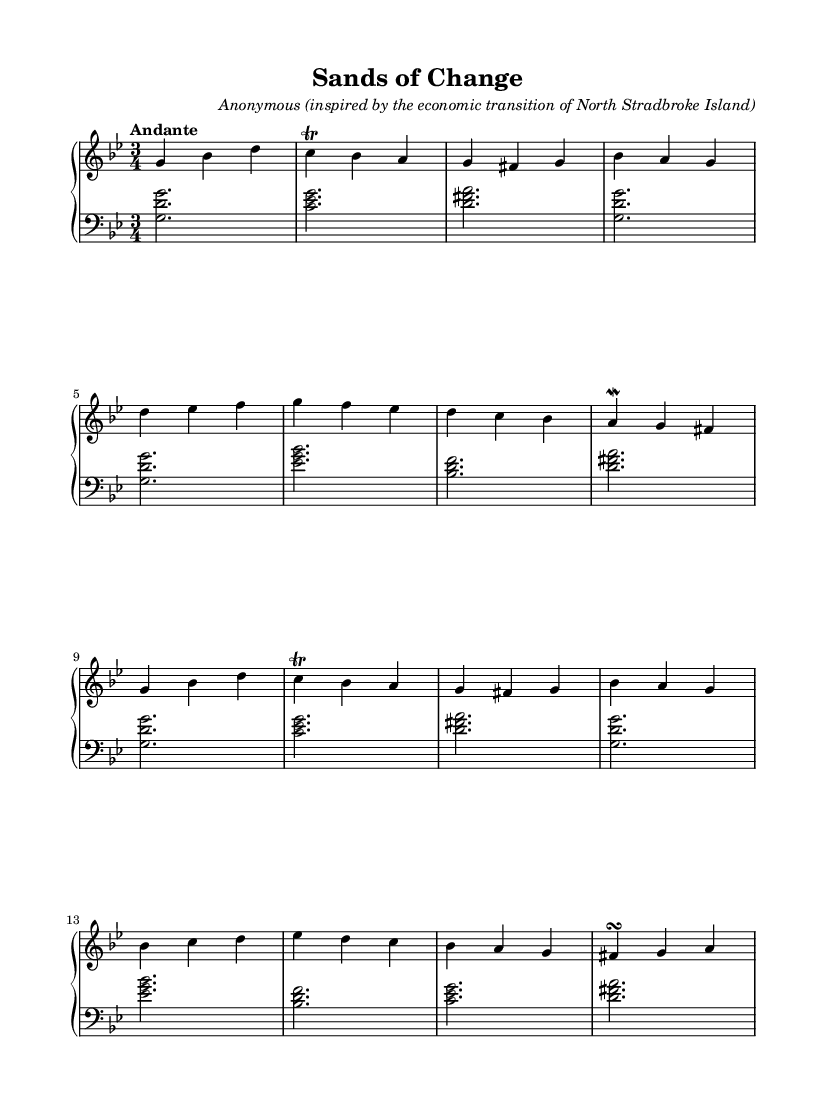What is the key signature of this music? The key signature indicates G minor, which has two flats (B♭ and E♭). This can be identified by looking at the key signature at the beginning of the music.
Answer: G minor What is the time signature of this piece? The time signature is 3/4, as indicated near the beginning of the music. This means there are three beats in each measure, and a quarter note receives one beat.
Answer: 3/4 What is the tempo marking for this piece? The tempo marking is Andante, which is typically understood to mean a moderate pace. This is noted at the beginning of the score, under the tempo indication.
Answer: Andante How many sections are there in the piece? The piece has four sections: Section A, Section B, Section A', and Section C. Each section is designated clearly in the music with letters.
Answer: Four What is the duration of the notes in the left hand during Section A? In Section A, the notes in the left hand are all half notes (notated as two beats each) followed by the last note which is a half note as well. This is identified by counting the rhythmic values in this section.
Answer: Half notes What musical technique is used in the right hand for Section A? The right hand in Section A uses a trill on the note C, which is a standard Baroque ornamentation to add embellishment to the melody by rapidly alternating between two adjacent notes. This is indicated by the notation seen above the note.
Answer: Trill Which composer is credited for this piece? The piece is credited to an anonymous composer who is inspired by the economic transition of North Stradbroke Island, as indicated in the header section of the score.
Answer: Anonymous 